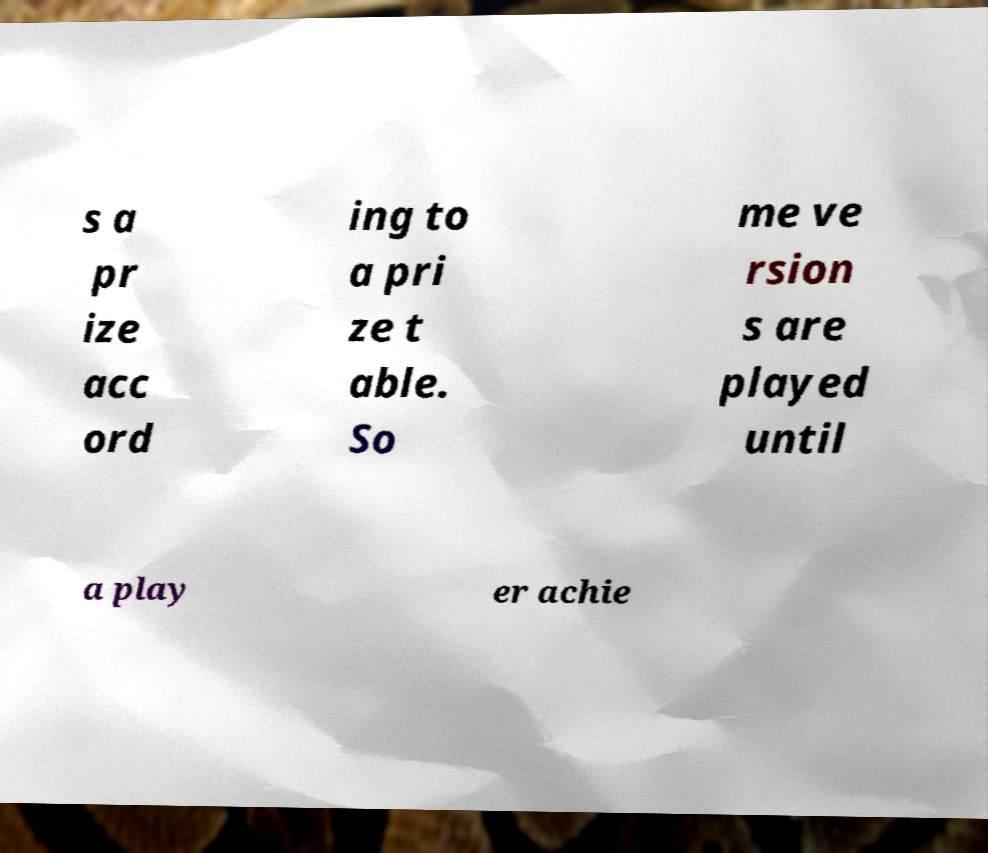Can you read and provide the text displayed in the image?This photo seems to have some interesting text. Can you extract and type it out for me? s a pr ize acc ord ing to a pri ze t able. So me ve rsion s are played until a play er achie 